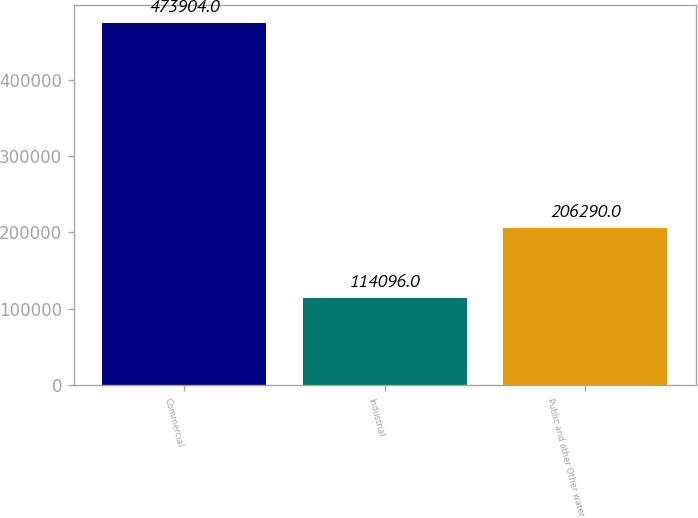<chart> <loc_0><loc_0><loc_500><loc_500><bar_chart><fcel>Commercial<fcel>Industrial<fcel>Public and other Other water<nl><fcel>473904<fcel>114096<fcel>206290<nl></chart> 